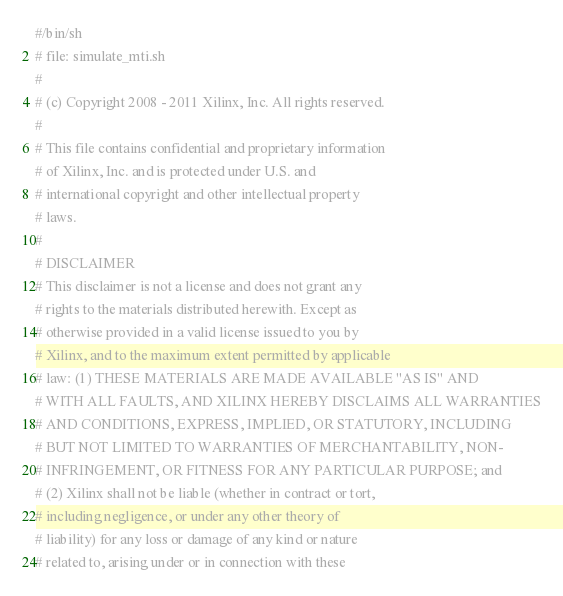Convert code to text. <code><loc_0><loc_0><loc_500><loc_500><_Bash_>#/bin/sh
# file: simulate_mti.sh
# 
# (c) Copyright 2008 - 2011 Xilinx, Inc. All rights reserved.
# 
# This file contains confidential and proprietary information
# of Xilinx, Inc. and is protected under U.S. and
# international copyright and other intellectual property
# laws.
# 
# DISCLAIMER
# This disclaimer is not a license and does not grant any
# rights to the materials distributed herewith. Except as
# otherwise provided in a valid license issued to you by
# Xilinx, and to the maximum extent permitted by applicable
# law: (1) THESE MATERIALS ARE MADE AVAILABLE "AS IS" AND
# WITH ALL FAULTS, AND XILINX HEREBY DISCLAIMS ALL WARRANTIES
# AND CONDITIONS, EXPRESS, IMPLIED, OR STATUTORY, INCLUDING
# BUT NOT LIMITED TO WARRANTIES OF MERCHANTABILITY, NON-
# INFRINGEMENT, OR FITNESS FOR ANY PARTICULAR PURPOSE; and
# (2) Xilinx shall not be liable (whether in contract or tort,
# including negligence, or under any other theory of
# liability) for any loss or damage of any kind or nature
# related to, arising under or in connection with these</code> 